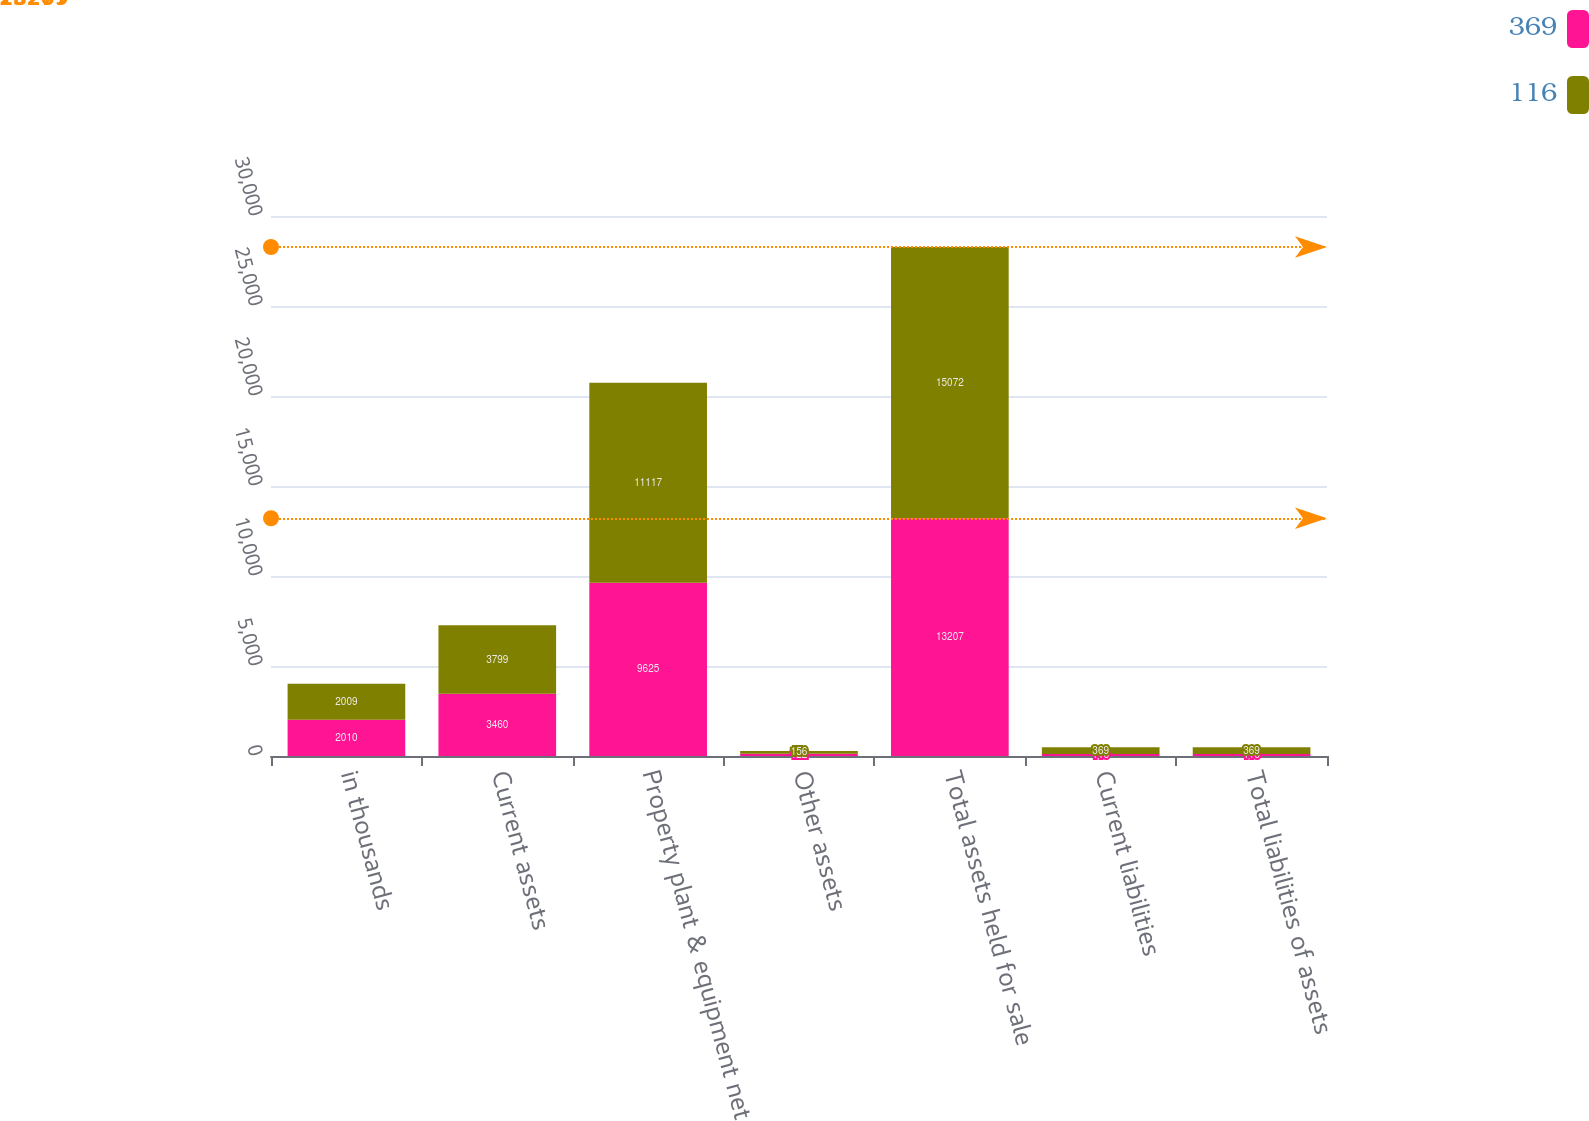Convert chart to OTSL. <chart><loc_0><loc_0><loc_500><loc_500><stacked_bar_chart><ecel><fcel>in thousands<fcel>Current assets<fcel>Property plant & equipment net<fcel>Other assets<fcel>Total assets held for sale<fcel>Current liabilities<fcel>Total liabilities of assets<nl><fcel>369<fcel>2010<fcel>3460<fcel>9625<fcel>122<fcel>13207<fcel>116<fcel>116<nl><fcel>116<fcel>2009<fcel>3799<fcel>11117<fcel>156<fcel>15072<fcel>369<fcel>369<nl></chart> 